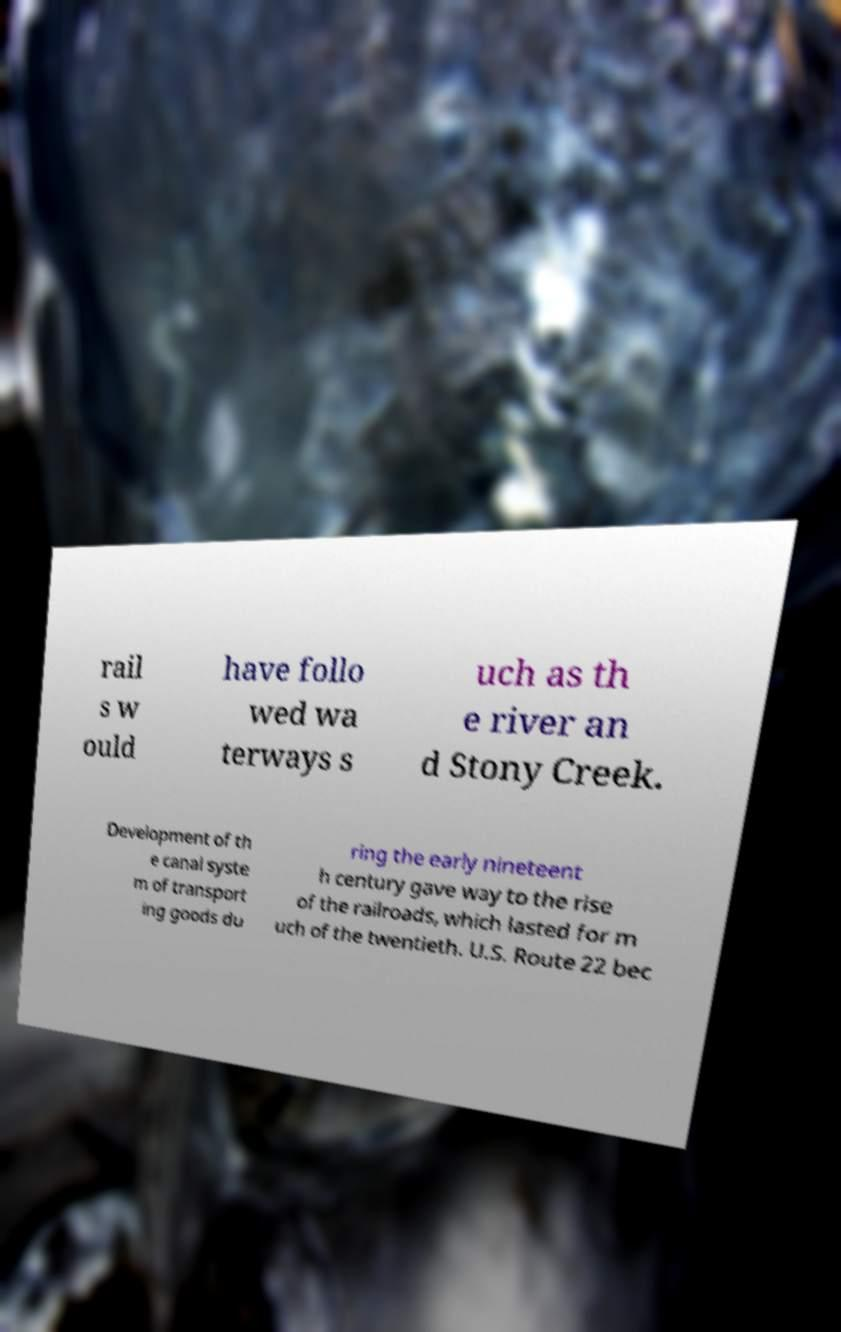Please read and relay the text visible in this image. What does it say? rail s w ould have follo wed wa terways s uch as th e river an d Stony Creek. Development of th e canal syste m of transport ing goods du ring the early nineteent h century gave way to the rise of the railroads, which lasted for m uch of the twentieth. U.S. Route 22 bec 